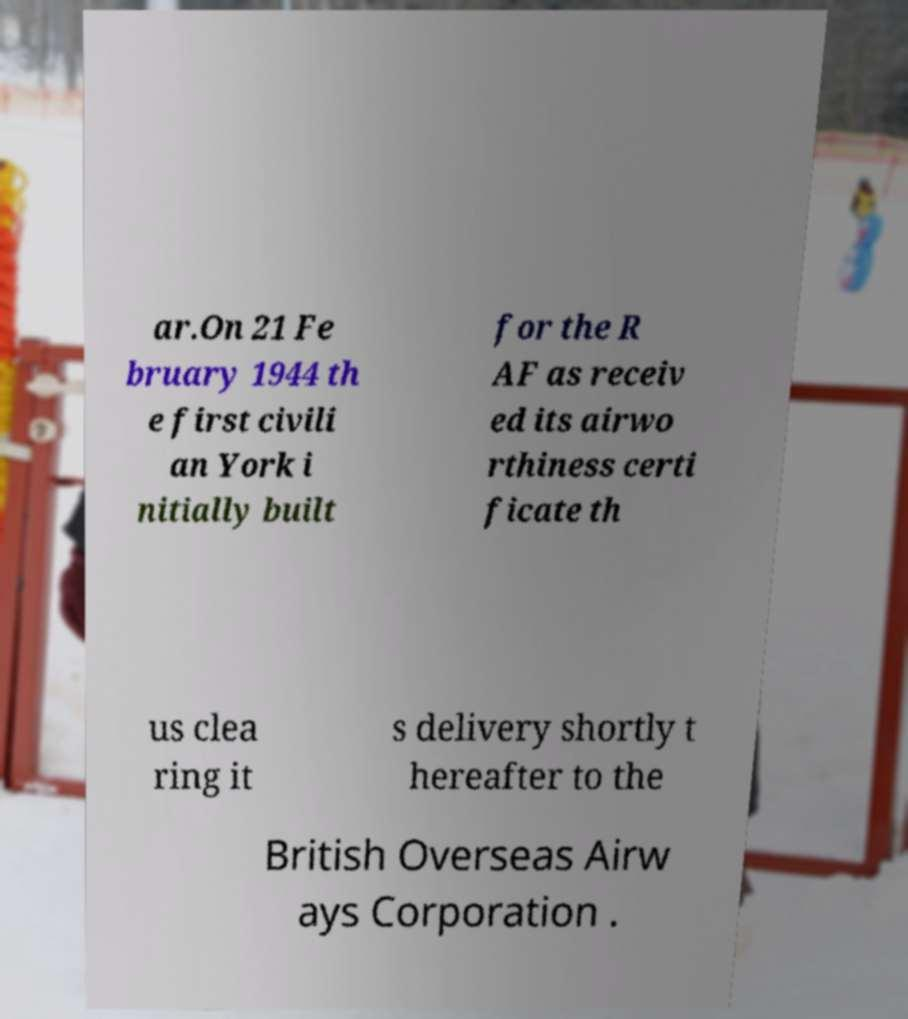What messages or text are displayed in this image? I need them in a readable, typed format. ar.On 21 Fe bruary 1944 th e first civili an York i nitially built for the R AF as receiv ed its airwo rthiness certi ficate th us clea ring it s delivery shortly t hereafter to the British Overseas Airw ays Corporation . 